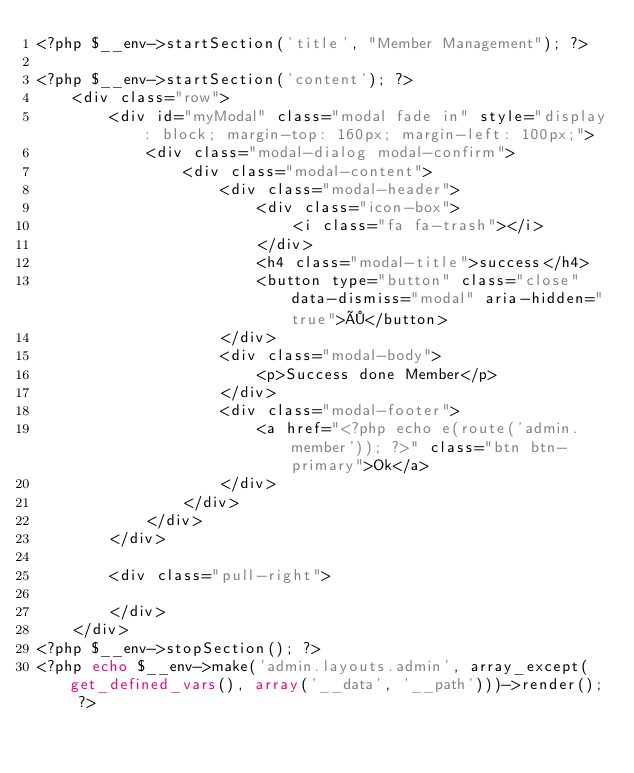Convert code to text. <code><loc_0><loc_0><loc_500><loc_500><_PHP_><?php $__env->startSection('title', "Member Management"); ?>

<?php $__env->startSection('content'); ?>
    <div class="row">
        <div id="myModal" class="modal fade in" style="display: block; margin-top: 160px; margin-left: 100px;">
            <div class="modal-dialog modal-confirm">
                <div class="modal-content">
                    <div class="modal-header">
                        <div class="icon-box">
                            <i class="fa fa-trash"></i>
                        </div>
                        <h4 class="modal-title">success</h4>
                        <button type="button" class="close" data-dismiss="modal" aria-hidden="true">×</button>
                    </div>
                    <div class="modal-body">
                        <p>Success done Member</p>
                    </div>
                    <div class="modal-footer">
                        <a href="<?php echo e(route('admin.member')); ?>" class="btn btn-primary">Ok</a>
                    </div>
                </div>
            </div>
        </div>

        <div class="pull-right">
            
        </div>
    </div>
<?php $__env->stopSection(); ?>
<?php echo $__env->make('admin.layouts.admin', array_except(get_defined_vars(), array('__data', '__path')))->render(); ?></code> 